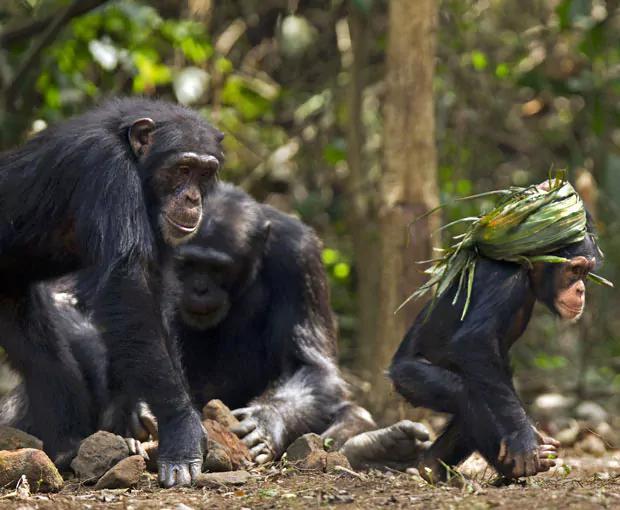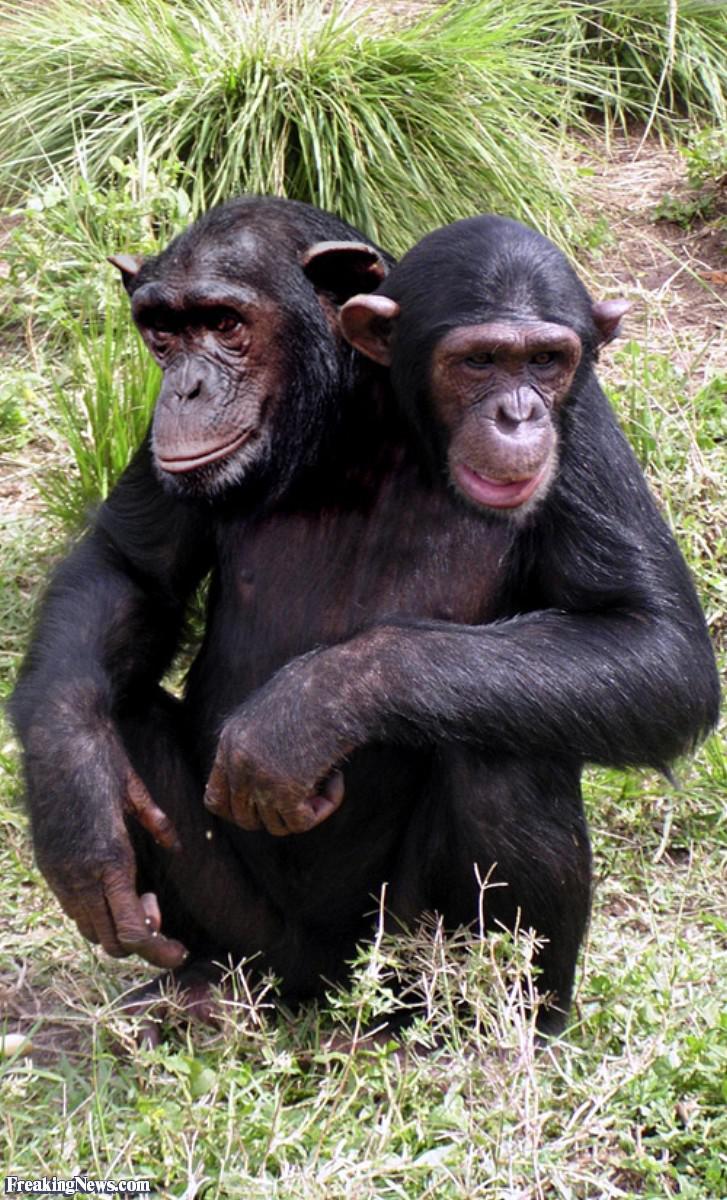The first image is the image on the left, the second image is the image on the right. Given the left and right images, does the statement "There are four chimpanzees." hold true? Answer yes or no. No. 